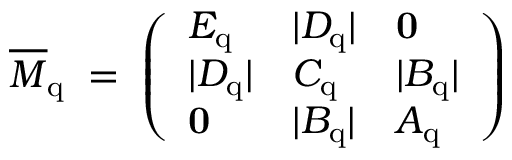Convert formula to latex. <formula><loc_0><loc_0><loc_500><loc_500>\overline { M } _ { q } \, = \, \left ( \begin{array} { l l l } { { E _ { q } } } & { { | D _ { q } | } } & { 0 } \\ { { | D _ { q } | } } & { { C _ { q } } } & { { | B _ { q } | } } \\ { 0 } & { { | B _ { q } | } } & { { A _ { q } } } \end{array} \right ) \,</formula> 